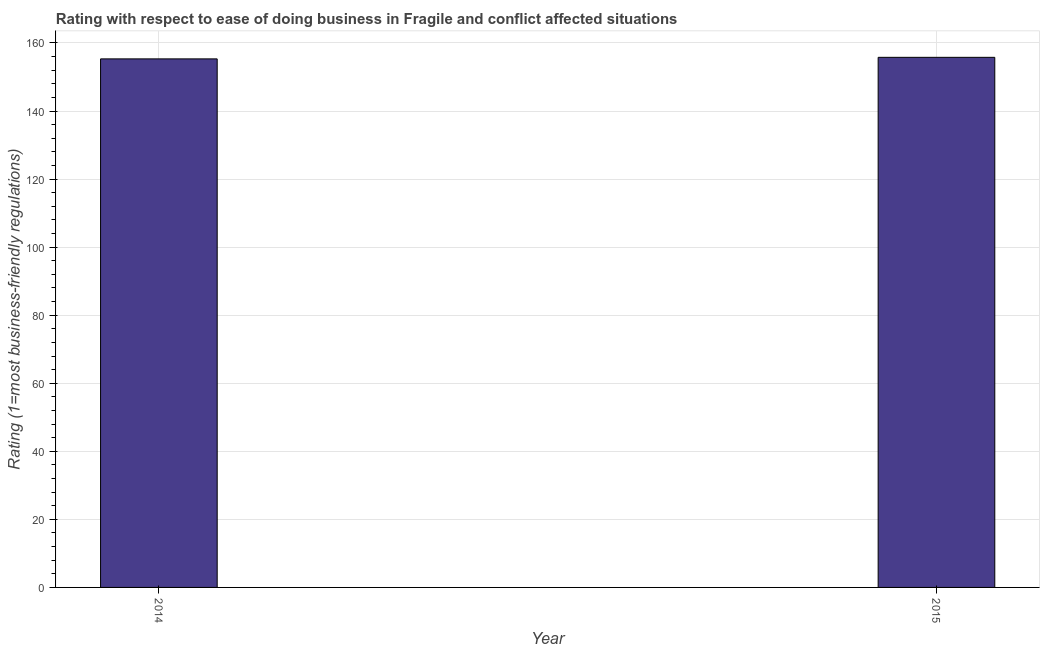Does the graph contain any zero values?
Make the answer very short. No. Does the graph contain grids?
Provide a short and direct response. Yes. What is the title of the graph?
Your response must be concise. Rating with respect to ease of doing business in Fragile and conflict affected situations. What is the label or title of the X-axis?
Your answer should be compact. Year. What is the label or title of the Y-axis?
Provide a short and direct response. Rating (1=most business-friendly regulations). What is the ease of doing business index in 2015?
Offer a terse response. 155.79. Across all years, what is the maximum ease of doing business index?
Make the answer very short. 155.79. Across all years, what is the minimum ease of doing business index?
Offer a very short reply. 155.33. In which year was the ease of doing business index maximum?
Ensure brevity in your answer.  2015. In which year was the ease of doing business index minimum?
Make the answer very short. 2014. What is the sum of the ease of doing business index?
Ensure brevity in your answer.  311.12. What is the difference between the ease of doing business index in 2014 and 2015?
Keep it short and to the point. -0.46. What is the average ease of doing business index per year?
Your answer should be very brief. 155.56. What is the median ease of doing business index?
Provide a short and direct response. 155.56. In how many years, is the ease of doing business index greater than 104 ?
Your answer should be very brief. 2. Do a majority of the years between 2015 and 2014 (inclusive) have ease of doing business index greater than 16 ?
Give a very brief answer. No. Are all the bars in the graph horizontal?
Provide a short and direct response. No. How many years are there in the graph?
Provide a short and direct response. 2. What is the difference between two consecutive major ticks on the Y-axis?
Provide a succinct answer. 20. What is the Rating (1=most business-friendly regulations) of 2014?
Provide a succinct answer. 155.33. What is the Rating (1=most business-friendly regulations) of 2015?
Keep it short and to the point. 155.79. What is the difference between the Rating (1=most business-friendly regulations) in 2014 and 2015?
Offer a very short reply. -0.45. What is the ratio of the Rating (1=most business-friendly regulations) in 2014 to that in 2015?
Ensure brevity in your answer.  1. 